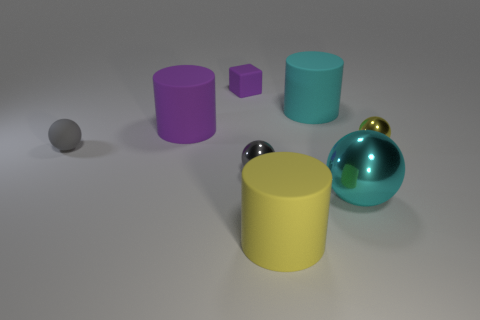What number of objects are either tiny matte objects in front of the yellow sphere or balls?
Your response must be concise. 4. What number of other things are the same size as the cyan ball?
Keep it short and to the point. 3. Are there the same number of tiny gray matte spheres on the right side of the large purple thing and yellow metal balls to the left of the large yellow matte object?
Your answer should be compact. Yes. What color is the matte object that is the same shape as the big shiny object?
Ensure brevity in your answer.  Gray. Is there any other thing that has the same shape as the small purple rubber object?
Your answer should be compact. No. Does the tiny object that is in front of the small gray rubber sphere have the same color as the rubber sphere?
Ensure brevity in your answer.  Yes. There is another gray object that is the same shape as the tiny gray metallic object; what size is it?
Keep it short and to the point. Small. How many yellow balls have the same material as the small yellow object?
Provide a succinct answer. 0. Is there a yellow matte thing left of the cylinder that is in front of the tiny shiny object right of the big cyan sphere?
Your answer should be compact. No. The tiny purple matte object has what shape?
Your answer should be compact. Cube. 